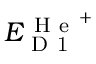<formula> <loc_0><loc_0><loc_500><loc_500>E _ { D 1 } ^ { H e ^ { + } }</formula> 